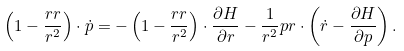Convert formula to latex. <formula><loc_0><loc_0><loc_500><loc_500>\left ( { 1 } - \frac { { r } { r } } { r ^ { 2 } } \right ) \cdot \dot { p } = - \left ( { 1 } - \frac { { r } { r } } { r ^ { 2 } } \right ) \cdot \frac { \partial H } { \partial { r } } - \frac { 1 } { r ^ { 2 } } { p } { r } \cdot \left ( \dot { r } - \frac { \partial H } { \partial { p } } \right ) .</formula> 